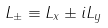<formula> <loc_0><loc_0><loc_500><loc_500>L _ { \pm } \equiv L _ { x } \pm i L _ { y }</formula> 